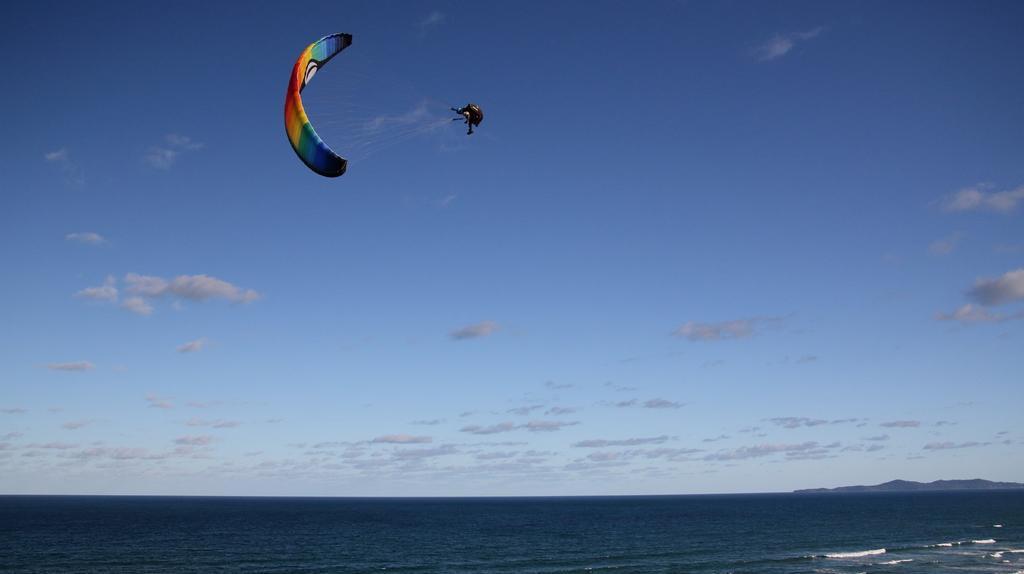How would you summarize this image in a sentence or two? In this picture I can see there is a person wearing a parachute and there is ocean here on the ground and the sky is clear. 